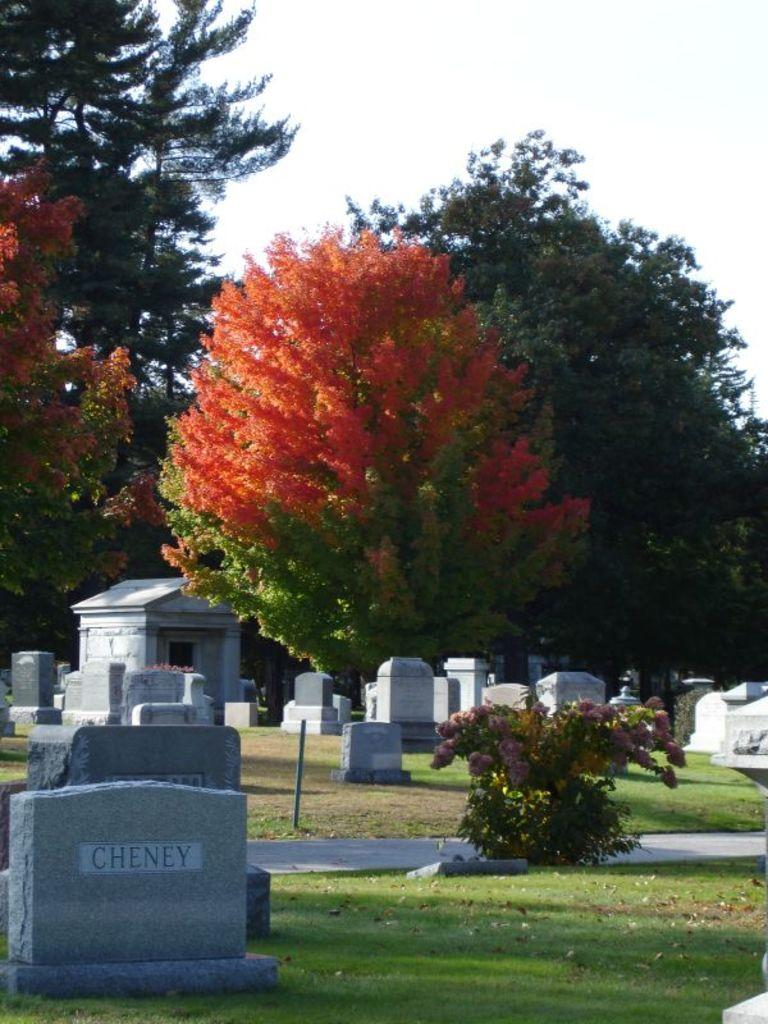What type of objects can be seen in the image? There are headstones in the image. What other elements can be found at the bottom of the image? There is a plant at the bottom of the image. What can be seen in the middle of the image? Trees are present in the middle of the image. What is visible in the background of the image? The sky is visible in the background of the image. How many balls are visible in the image? There are no balls present in the image. Is there a man standing near the headstones in the image? There is no man present in the image. 